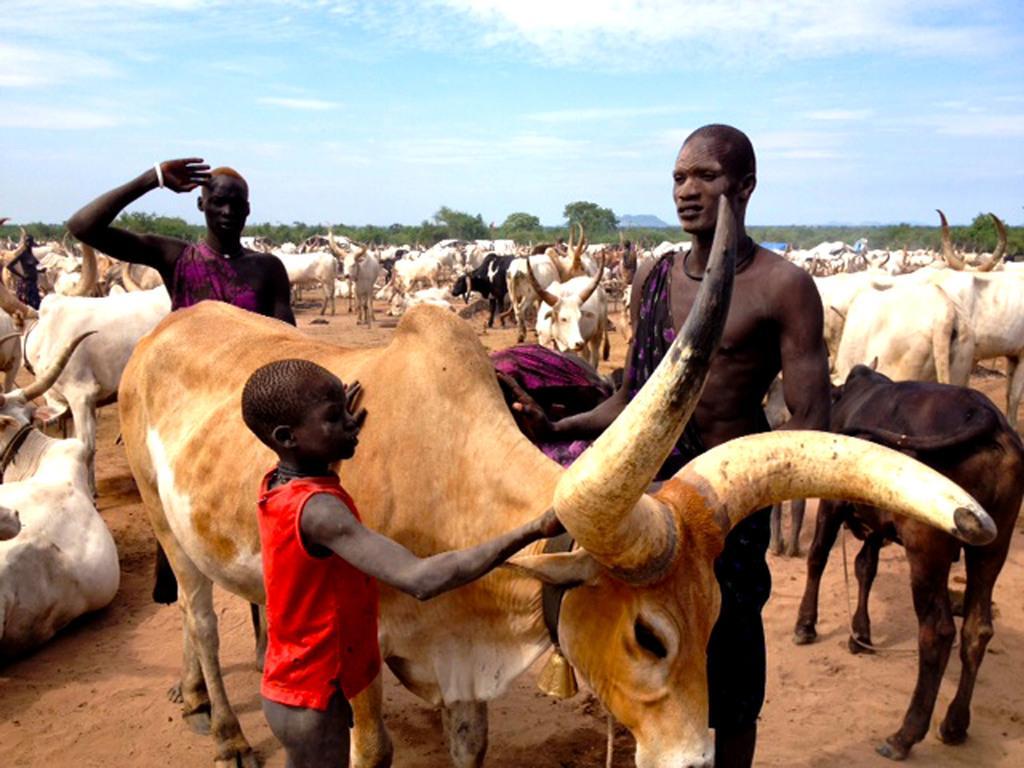Could you give a brief overview of what you see in this image? This image is taken outdoors. At the top of the image there is a sky with clouds. In the background there are many trees and plants. At the bottom of the image there is a ground. In the middle of the image there are a few men and there are many cattles. 